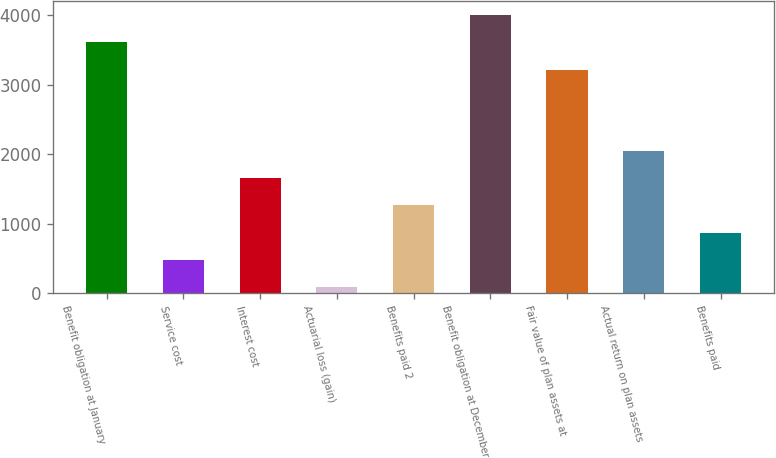Convert chart to OTSL. <chart><loc_0><loc_0><loc_500><loc_500><bar_chart><fcel>Benefit obligation at January<fcel>Service cost<fcel>Interest cost<fcel>Actuarial loss (gain)<fcel>Benefits paid 2<fcel>Benefit obligation at December<fcel>Fair value of plan assets at<fcel>Actual return on plan assets<fcel>Benefits paid<nl><fcel>3618<fcel>479.7<fcel>1651.8<fcel>89<fcel>1261.1<fcel>4008.7<fcel>3214.6<fcel>2042.5<fcel>870.4<nl></chart> 